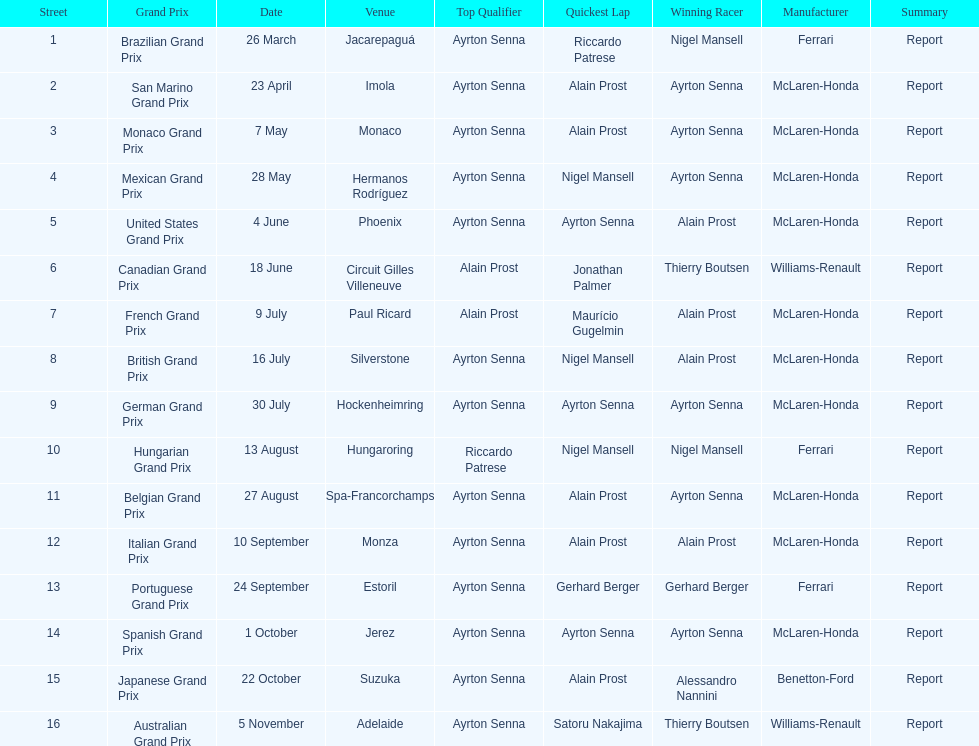What grand prix was before the san marino grand prix? Brazilian Grand Prix. 